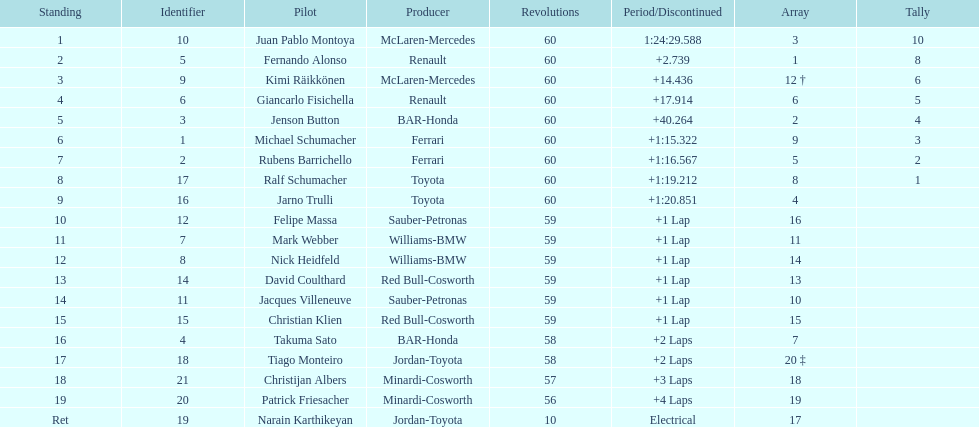How many drivers received points from the race? 8. 